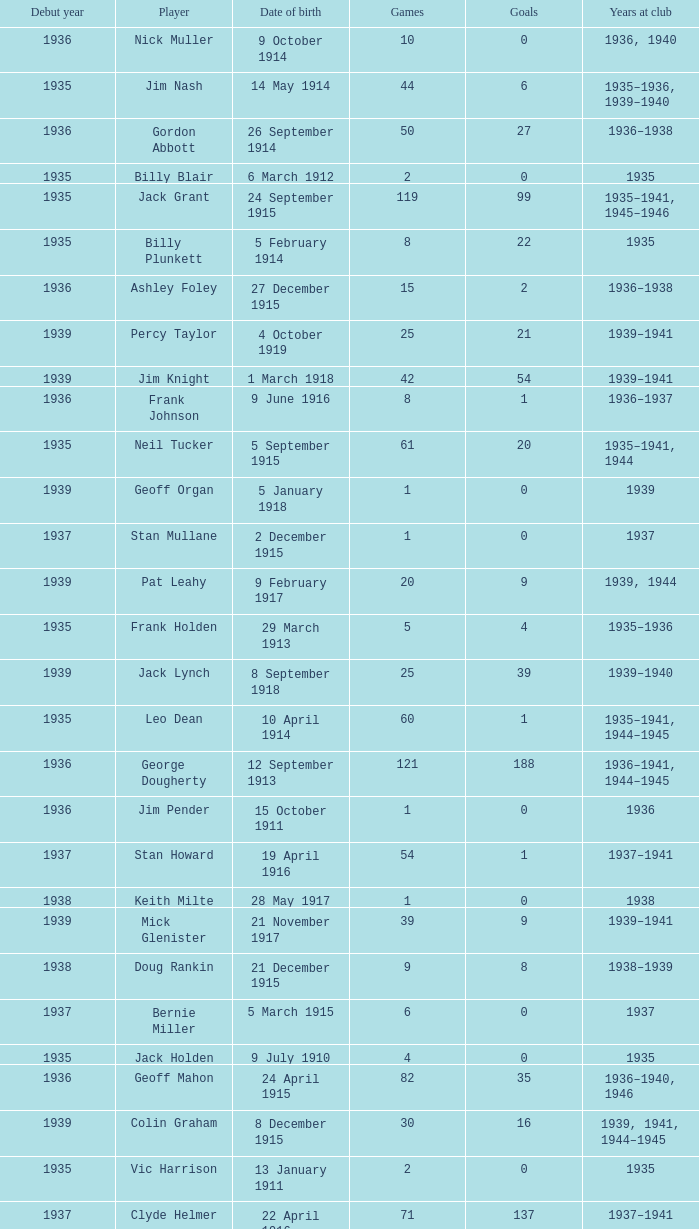How many years has the player who scored 2 goals and was born on july 23, 1910, been at the club? 1936.0. 